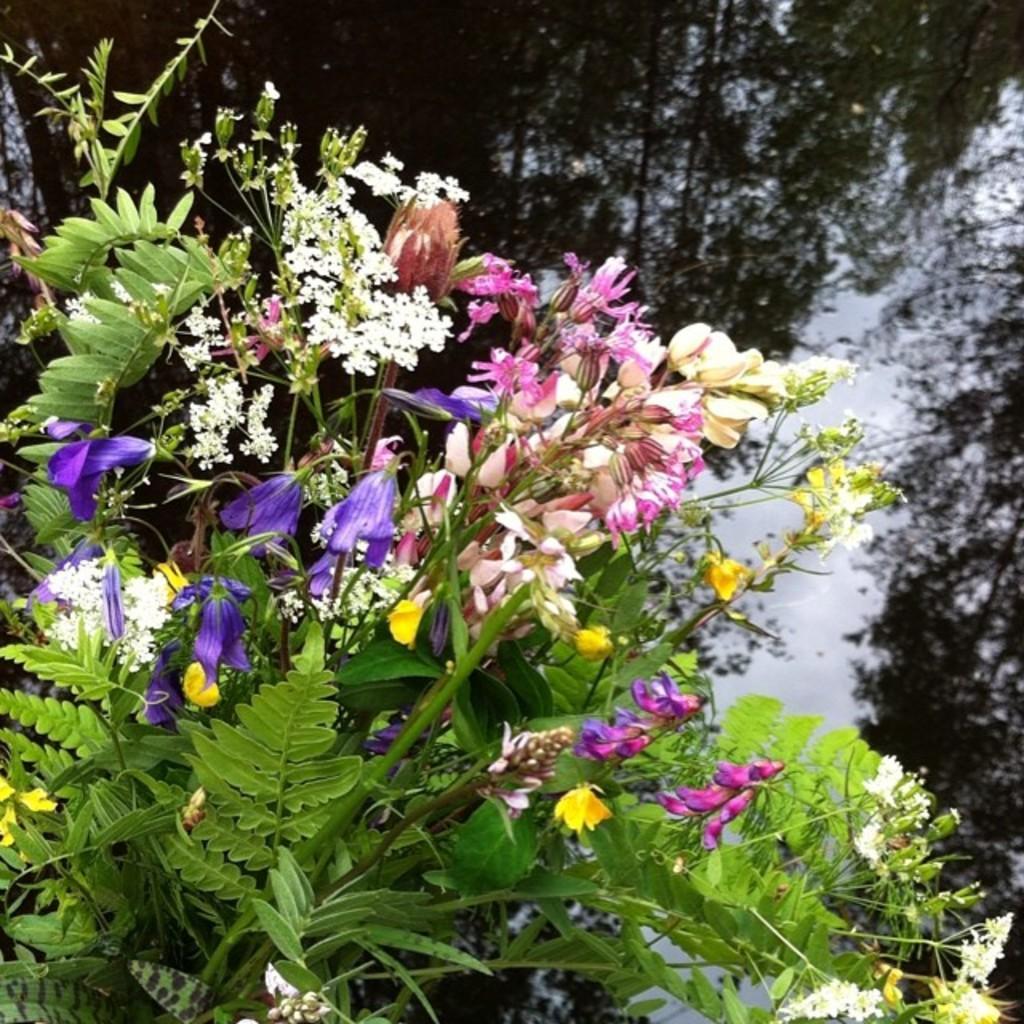In one or two sentences, can you explain what this image depicts? In this picture we can see some plants and flowers in the front, in the background there is water, we can see reflection of trees on the water. 